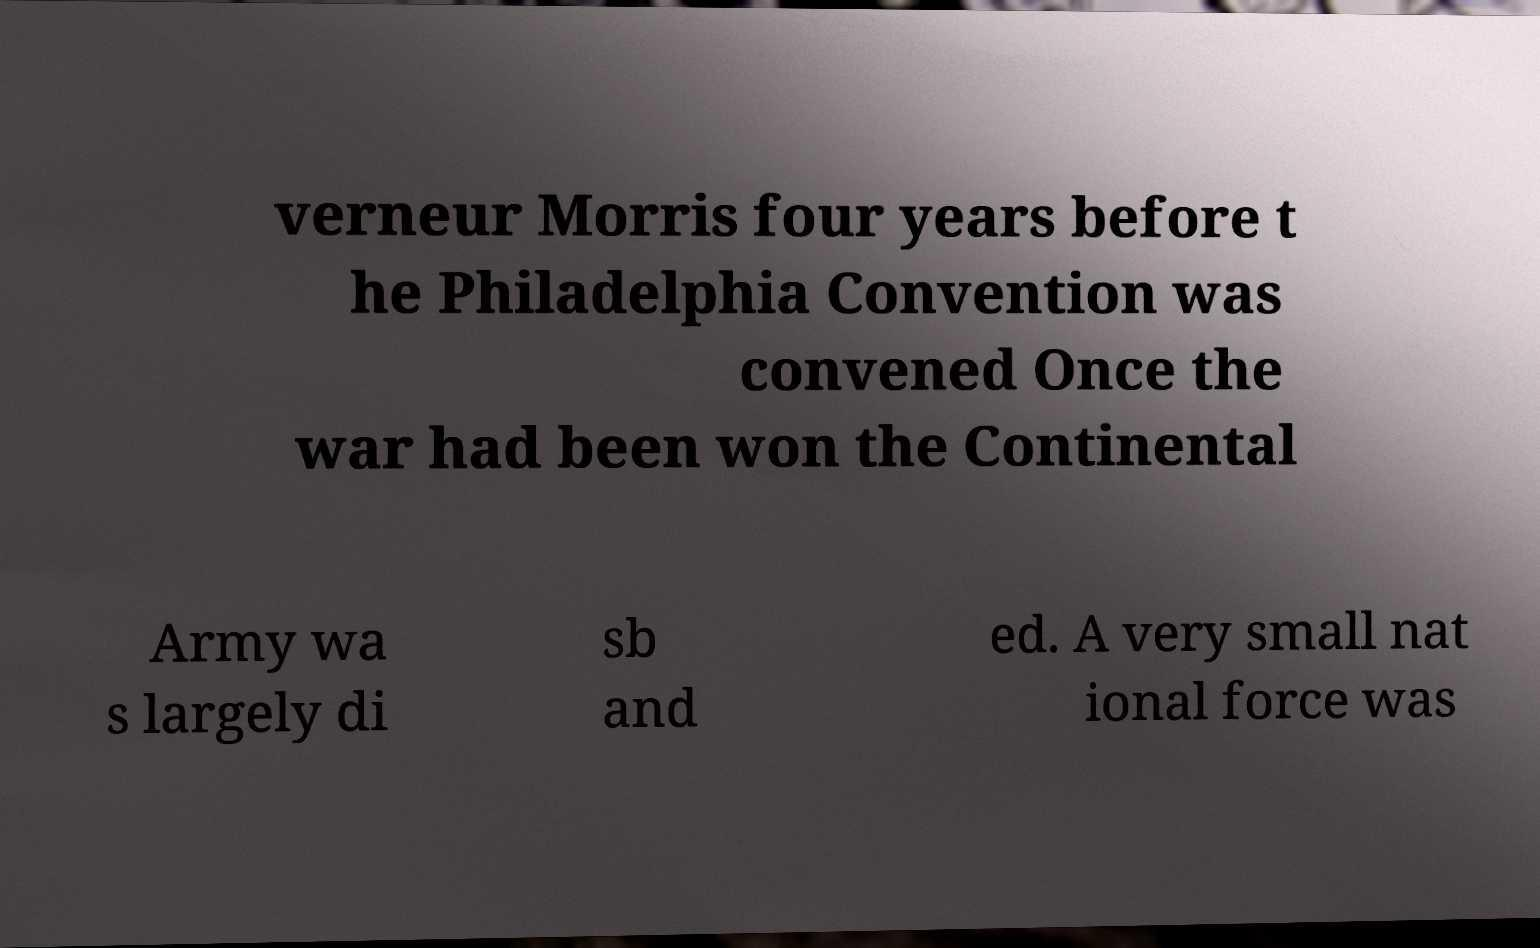Could you assist in decoding the text presented in this image and type it out clearly? verneur Morris four years before t he Philadelphia Convention was convened Once the war had been won the Continental Army wa s largely di sb and ed. A very small nat ional force was 